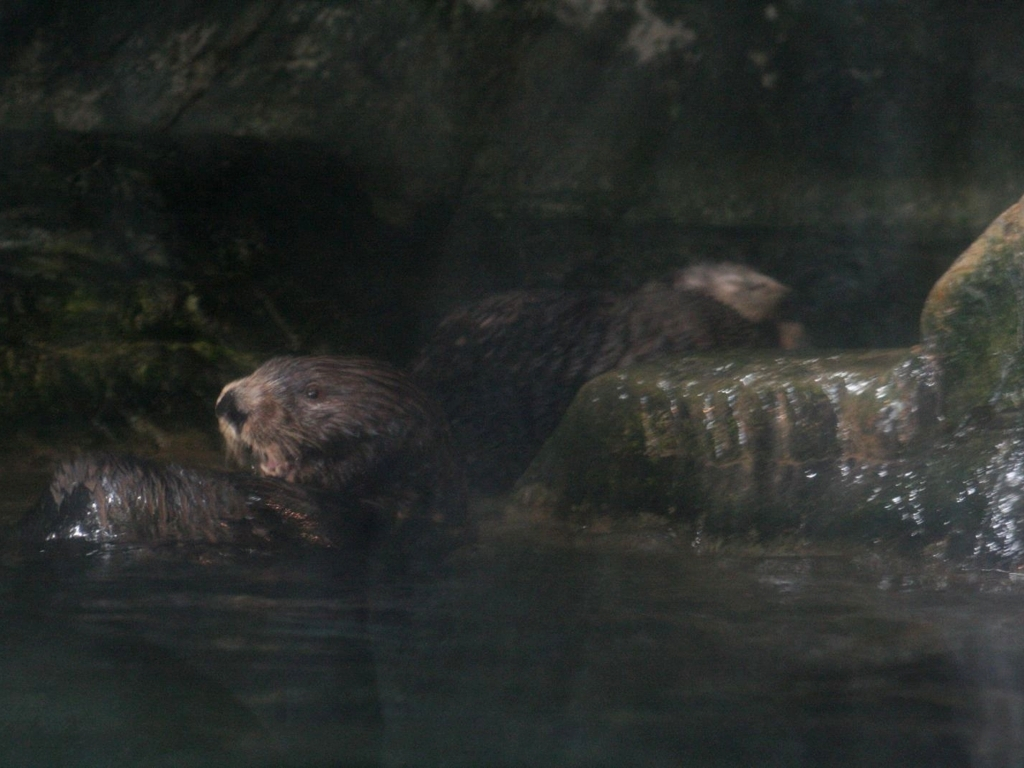Does the image contain noise? Yes, the image does display visual noise, which is indicated by the graininess and lack of clarity in some areas. Visual noise often occurs due to low lighting, high ISO settings, or other limitations in camera sensors. 